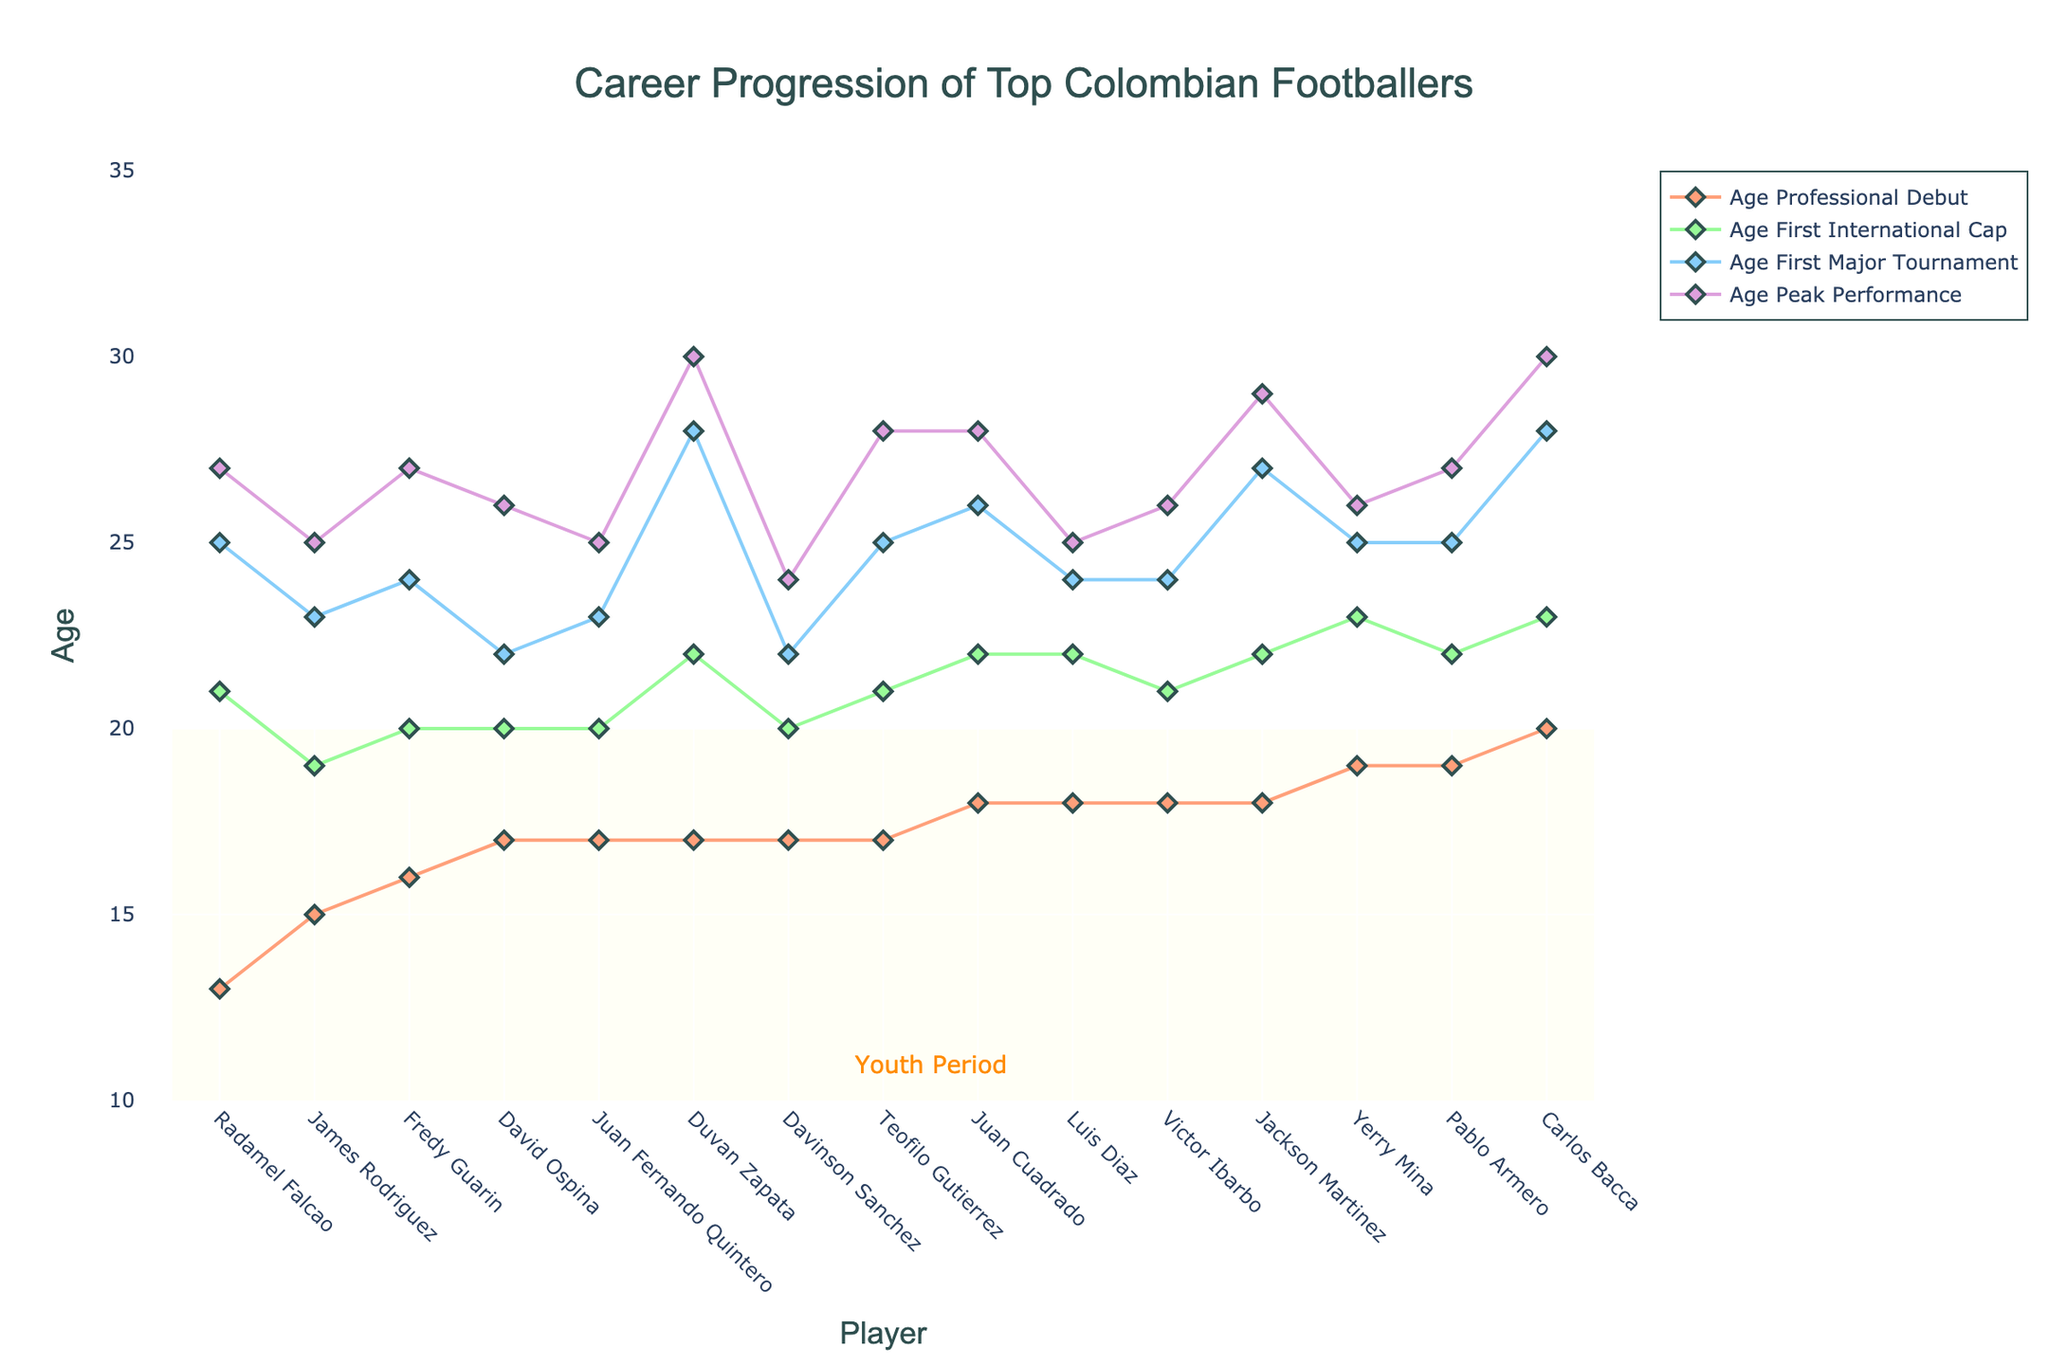Which player had the earliest professional debut? Look at the 'Age Professional Debut' line and find the lowest point. Falcao debuted at age 13.
Answer: Radamel Falcao Which players had their peak performance at age 25? Check the 'Age Peak Performance' line and identify the players at age 25. Both James Rodriguez and Luis Diaz peak at 25.
Answer: James Rodriguez, Luis Diaz Who took the longest time from professional debut to first international cap? Calculate the differences for all players and find the largest. Carlos Bacca took 3 years (23-20).
Answer: Carlos Bacca What is the average age of achieving the first major tournament among the players? Sum all 'Age First Major Tournament' values and divide by the number of players (15). Average = (23+25+26+22+28+24+25+23+28+22+24+24+27+25+25)/15 = 24.73.
Answer: 24.73 Who had the shortest time between professional debut and peak performance? Find the differences for all players and identify the smallest. James Rodriguez (25-15=10).
Answer: James Rodriguez Which player’s first international cap is closest to their professional debut? Subtract the 'Age Professional Debut' from 'Age First International Cap' and find the smallest difference. Falcao’s difference is 8 (13 to 21).
Answer: Radamel Falcao Who had the earliest peak performance? Check the ages in the 'Age Peak Performance' line and find the lowest. Davinson Sanchez peaked at age 24.
Answer: Davinson Sanchez Is there any player who had their major tournament appearance before their first international cap? Compare 'Age Major Tournament' and 'Age First International Cap' for all players. None had this sequence.
Answer: No How many players made their professional debut before turning 18? Count players with a 'Age Professional Debut' value less than 18. There are 8 such players.
Answer: 8 Which player had the largest gap between their first major tournament and peak performance? Subtract the 'Age First Major Tournament' from 'Age Peak Performance' for each player, identify the largest gap. Duvan Zapata's gap is 2 years (30-28=2).
Answer: Duvan Zapata 